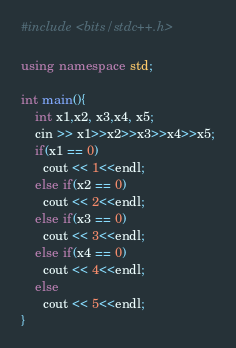<code> <loc_0><loc_0><loc_500><loc_500><_C++_>#include <bits/stdc++.h>

using namespace std;

int main(){
	int x1,x2, x3,x4, x5;
  	cin >> x1>>x2>>x3>>x4>>x5;
  	if(x1 == 0)
      cout << 1<<endl;
	else if(x2 == 0)
      cout << 2<<endl;
 	else if(x3 == 0)
      cout << 3<<endl;
  	else if(x4 == 0)
      cout << 4<<endl;
 	else
      cout << 5<<endl;
}</code> 